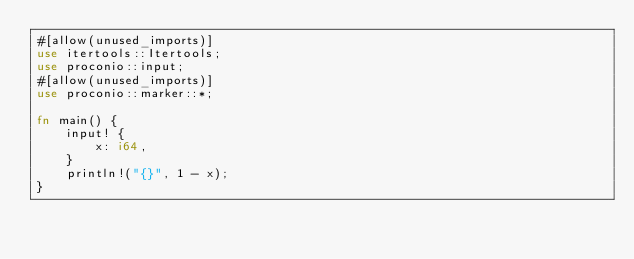<code> <loc_0><loc_0><loc_500><loc_500><_Rust_>#[allow(unused_imports)]
use itertools::Itertools;
use proconio::input;
#[allow(unused_imports)]
use proconio::marker::*;

fn main() {
    input! {
        x: i64,
    }
    println!("{}", 1 - x);
}
</code> 